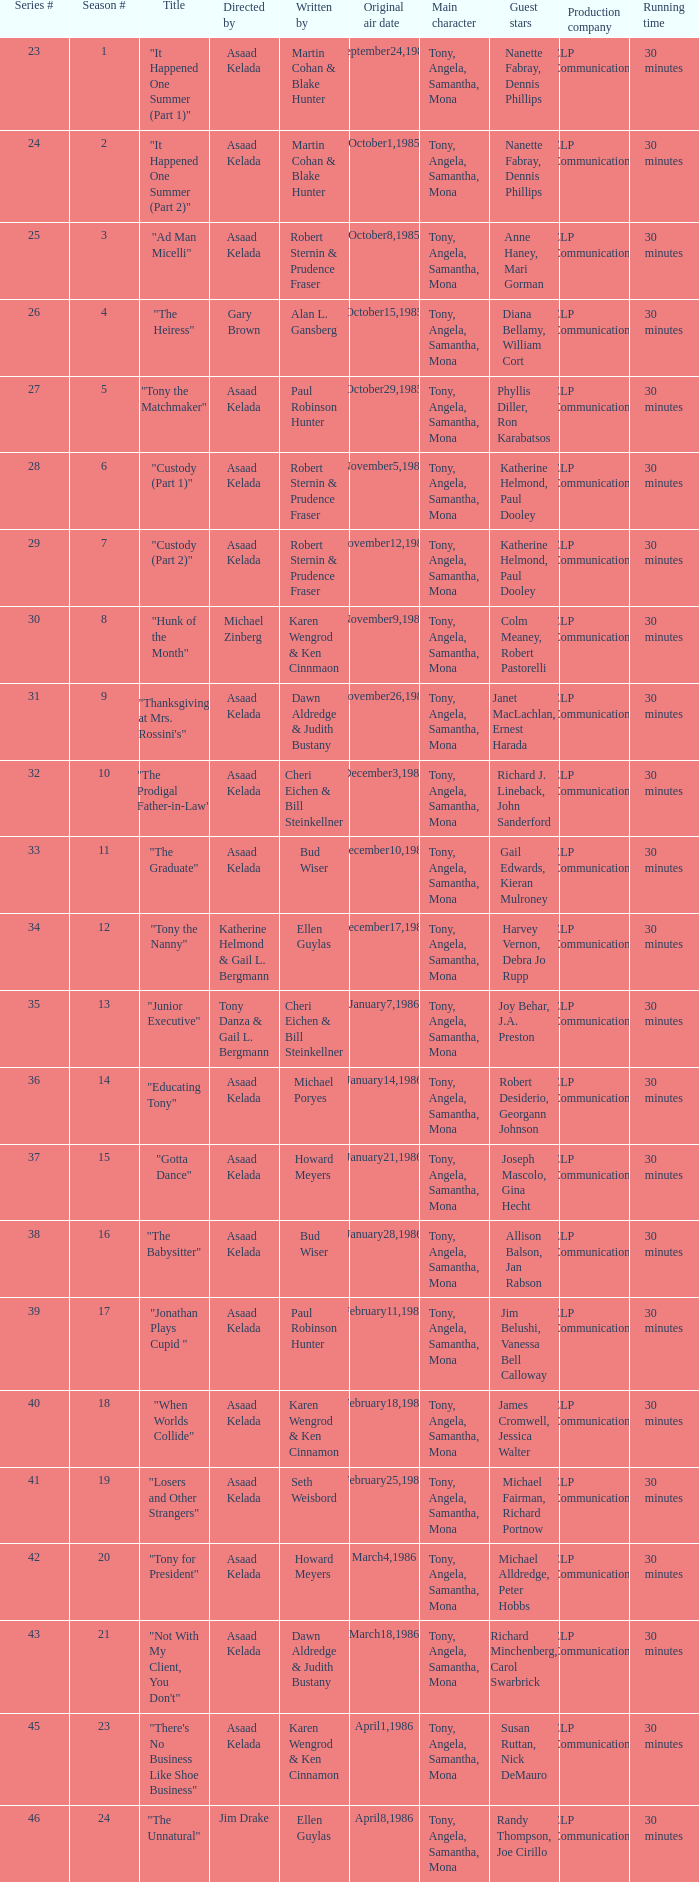What season features writer Michael Poryes? 14.0. 